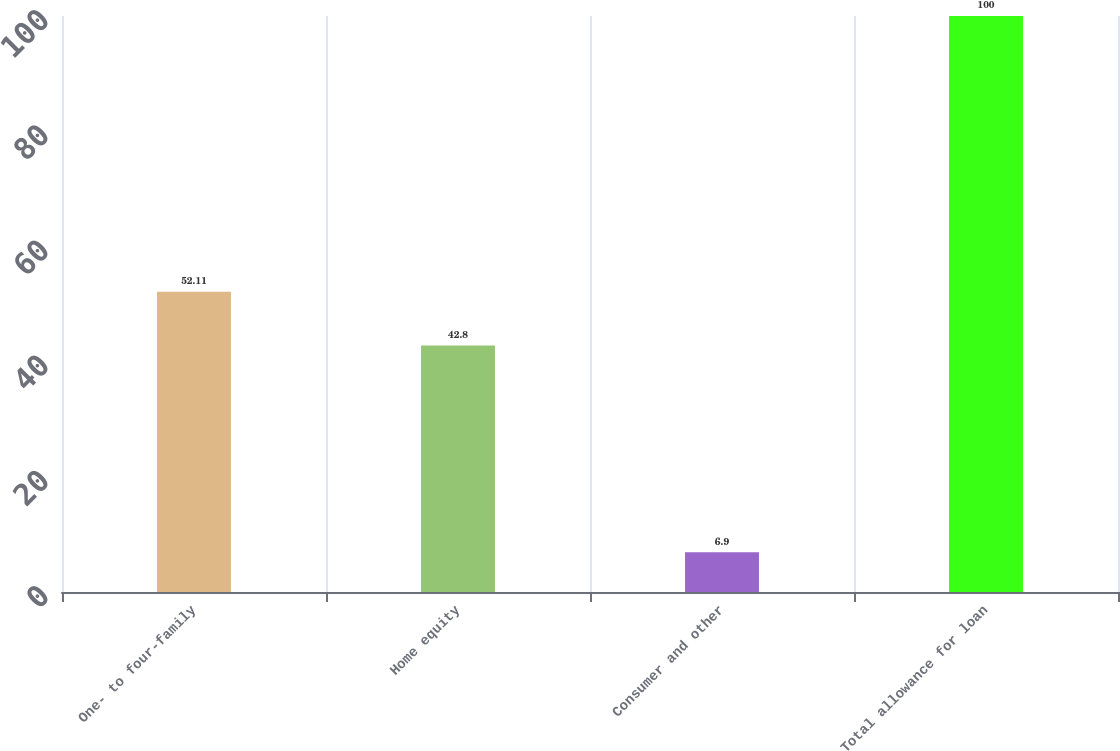Convert chart. <chart><loc_0><loc_0><loc_500><loc_500><bar_chart><fcel>One- to four-family<fcel>Home equity<fcel>Consumer and other<fcel>Total allowance for loan<nl><fcel>52.11<fcel>42.8<fcel>6.9<fcel>100<nl></chart> 